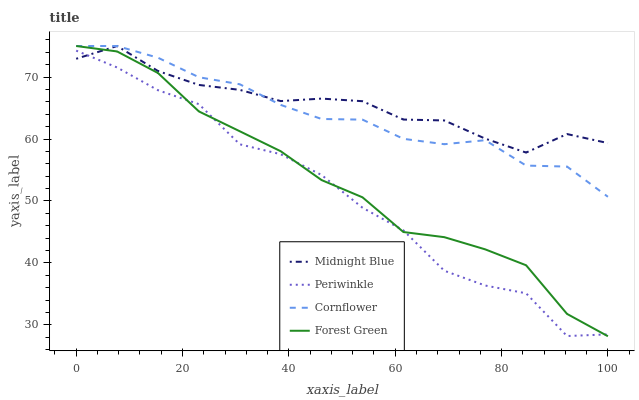Does Periwinkle have the minimum area under the curve?
Answer yes or no. Yes. Does Midnight Blue have the maximum area under the curve?
Answer yes or no. Yes. Does Forest Green have the minimum area under the curve?
Answer yes or no. No. Does Forest Green have the maximum area under the curve?
Answer yes or no. No. Is Forest Green the smoothest?
Answer yes or no. Yes. Is Periwinkle the roughest?
Answer yes or no. Yes. Is Periwinkle the smoothest?
Answer yes or no. No. Is Forest Green the roughest?
Answer yes or no. No. Does Periwinkle have the lowest value?
Answer yes or no. No. Does Periwinkle have the highest value?
Answer yes or no. No. Is Periwinkle less than Cornflower?
Answer yes or no. Yes. Is Cornflower greater than Periwinkle?
Answer yes or no. Yes. Does Periwinkle intersect Cornflower?
Answer yes or no. No. 